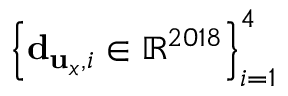<formula> <loc_0><loc_0><loc_500><loc_500>\left \{ { d } _ { { u } _ { x } , i } \in \mathbb { R } ^ { 2 0 1 8 } \right \} _ { i = 1 } ^ { 4 }</formula> 